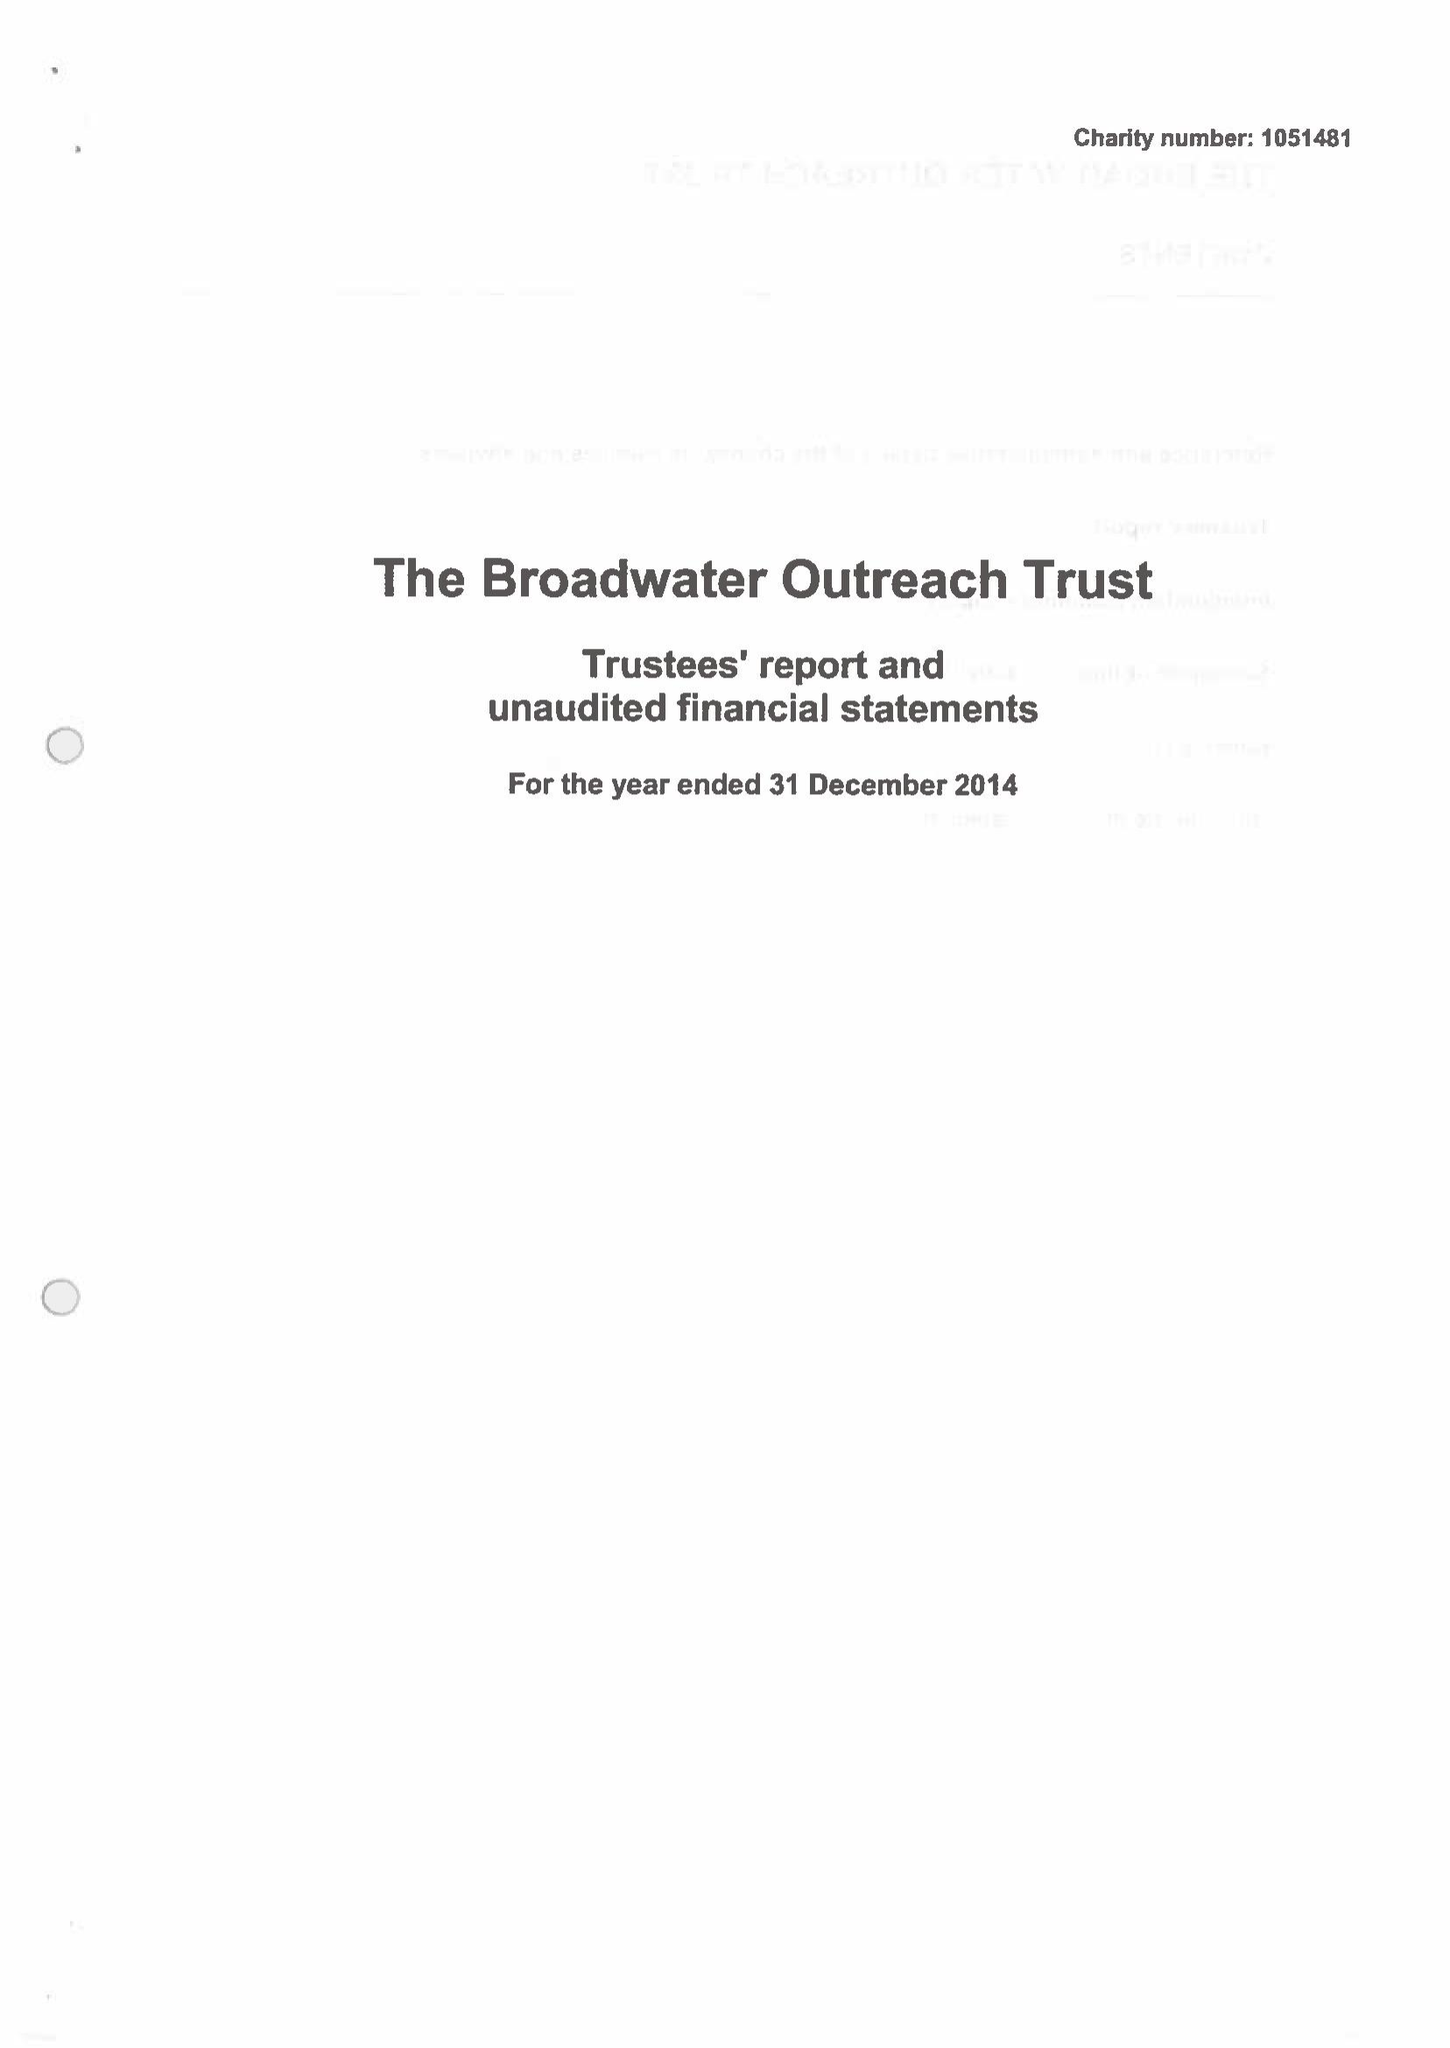What is the value for the charity_name?
Answer the question using a single word or phrase. The Broadwater Outreach Trust 